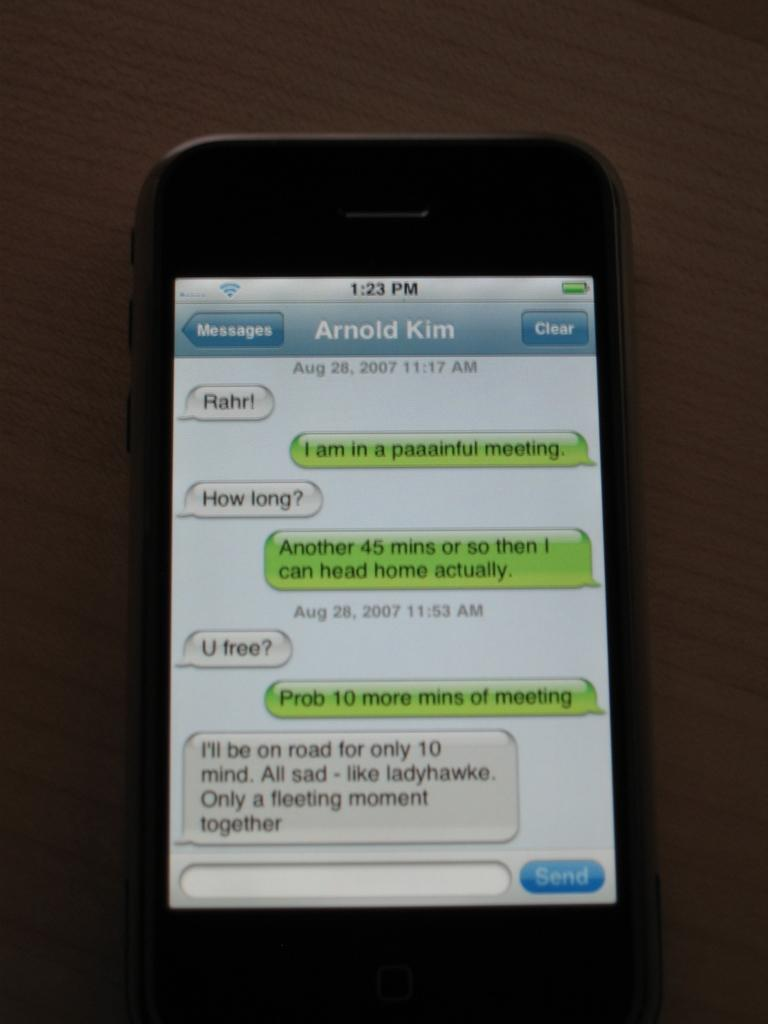<image>
Share a concise interpretation of the image provided. an iphone opened up to messages screen with the name 'arnold kim' 